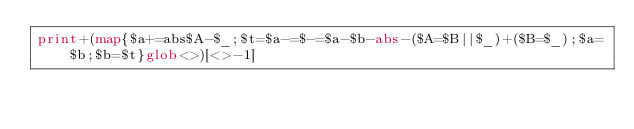Convert code to text. <code><loc_0><loc_0><loc_500><loc_500><_Perl_>print+(map{$a+=abs$A-$_;$t=$a-=$-=$a-$b-abs-($A=$B||$_)+($B=$_);$a=$b;$b=$t}glob<>)[<>-1]</code> 